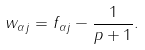<formula> <loc_0><loc_0><loc_500><loc_500>w _ { \alpha j } = f _ { \alpha j } - \frac { 1 } { p + 1 } .</formula> 